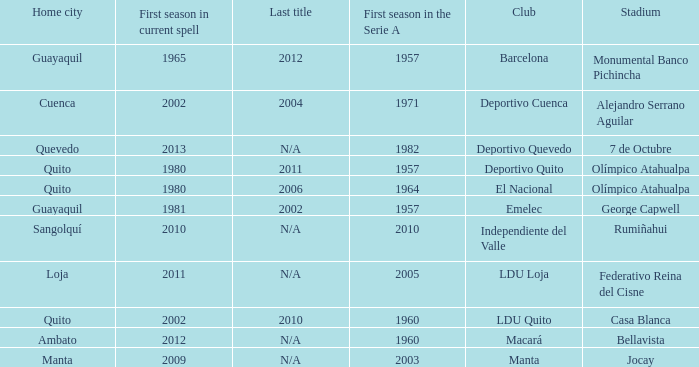Name the first season in the series for 2006 1964.0. 